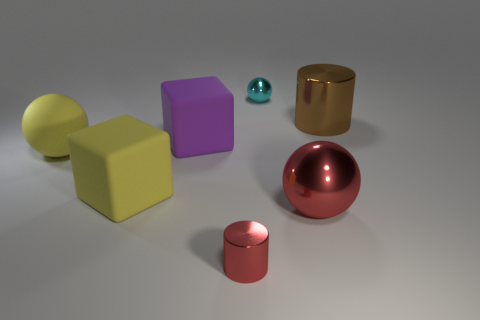Are there any large red spheres made of the same material as the large cylinder?
Provide a short and direct response. Yes. There is a large brown shiny object in front of the tiny cyan thing; what is its shape?
Offer a terse response. Cylinder. There is a big ball in front of the yellow matte cube; does it have the same color as the tiny shiny cylinder?
Offer a very short reply. Yes. Are there fewer yellow spheres that are in front of the yellow matte block than tiny cyan shiny balls?
Provide a short and direct response. Yes. There is a large cylinder that is made of the same material as the tiny cyan ball; what color is it?
Your answer should be very brief. Brown. There is a purple block that is behind the red metallic sphere; what is its size?
Offer a terse response. Large. Are the purple cube and the big red sphere made of the same material?
Your answer should be very brief. No. Are there any big red balls to the left of the sphere behind the big yellow matte ball that is in front of the tiny cyan metal thing?
Your answer should be very brief. No. The tiny metallic ball has what color?
Your answer should be very brief. Cyan. There is another shiny thing that is the same size as the brown object; what color is it?
Ensure brevity in your answer.  Red. 